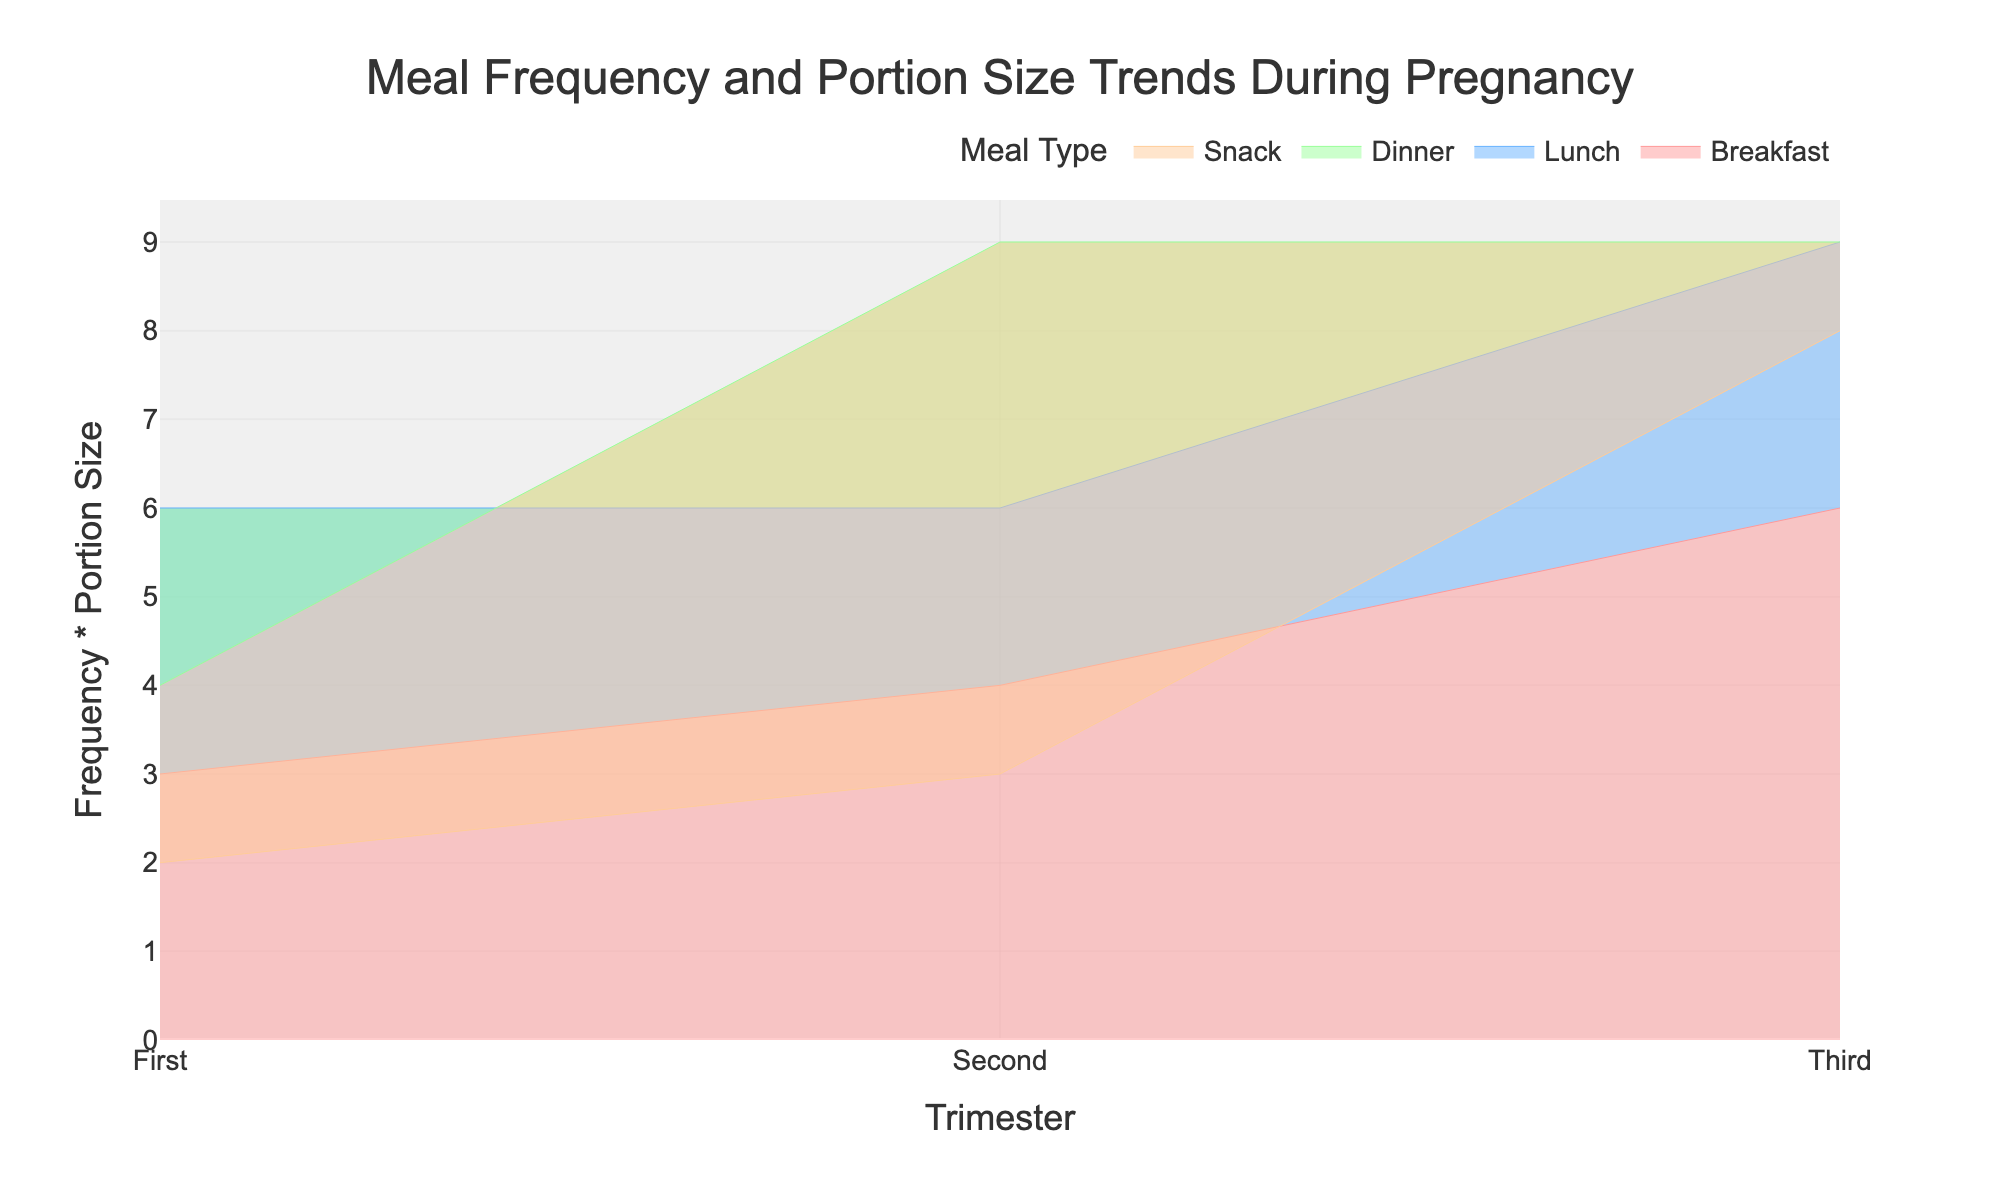What's the title of the chart? The title is displayed at the top of the chart, indicating the main topic.
Answer: Meal Frequency and Portion Size Trends During Pregnancy How does the frequency * portion size for breakfast change from the first to the third trimester? In the first trimester, it is 3 (Frequency) * 1 (Small) = 3. In the second trimester, it is 2 (Frequency) * 2 (Medium) = 4. In the third trimester, it is 3 (Frequency) * 2 (Medium) = 6.
Answer: It increases Which meal type has the largest value in the third trimester? By comparing the values for each meal in the third trimester, we find Dinner has 3 (Frequency) * 3 (Large) = 9, which is the highest.
Answer: Dinner What is the trend in snack portion sizes across trimesters? Portion sizes for snacks increase from Small in the first two trimesters to Medium in the third trimester.
Answer: They increase Which trimester shows the highest overall frequency * portion size for lunch? First trimester: Lunch is 3*2=6. Second trimester: Lunch is 3*2=6. Third trimester: Lunch is 3*3=9. The highest is in the third trimester.
Answer: Third What are the tick values displayed on the x-axis? The x-axis ticks denote the trimesters and are labeled as First, Second, and Third.
Answer: First, Second, Third Compare the change in frequency * portion size for Dinner from the first to the second trimester. In the first trimester, Dinner is 2 (Frequency) * 2 (Medium) = 4. In the second trimester, it is 3 (Frequency) * 3 (Large) = 9. The difference is 9 - 4 = 5.
Answer: It increases by 5 How does the meal frequency for snacks change over the trimesters? In the first trimester, snacks are consumed 2 times a day. In the second trimester, the frequency is 3 times a day. In the third trimester, it rises to 4 times a day.
Answer: It increases gradually Does the portion size for Lunch change from the first to the second trimester? No change is noted; both trimesters have a medium portion size for lunch.
Answer: No What color represents the Lunch meal type in the chart? By observing the plot, the color associated with Lunch is blue.
Answer: Blue 